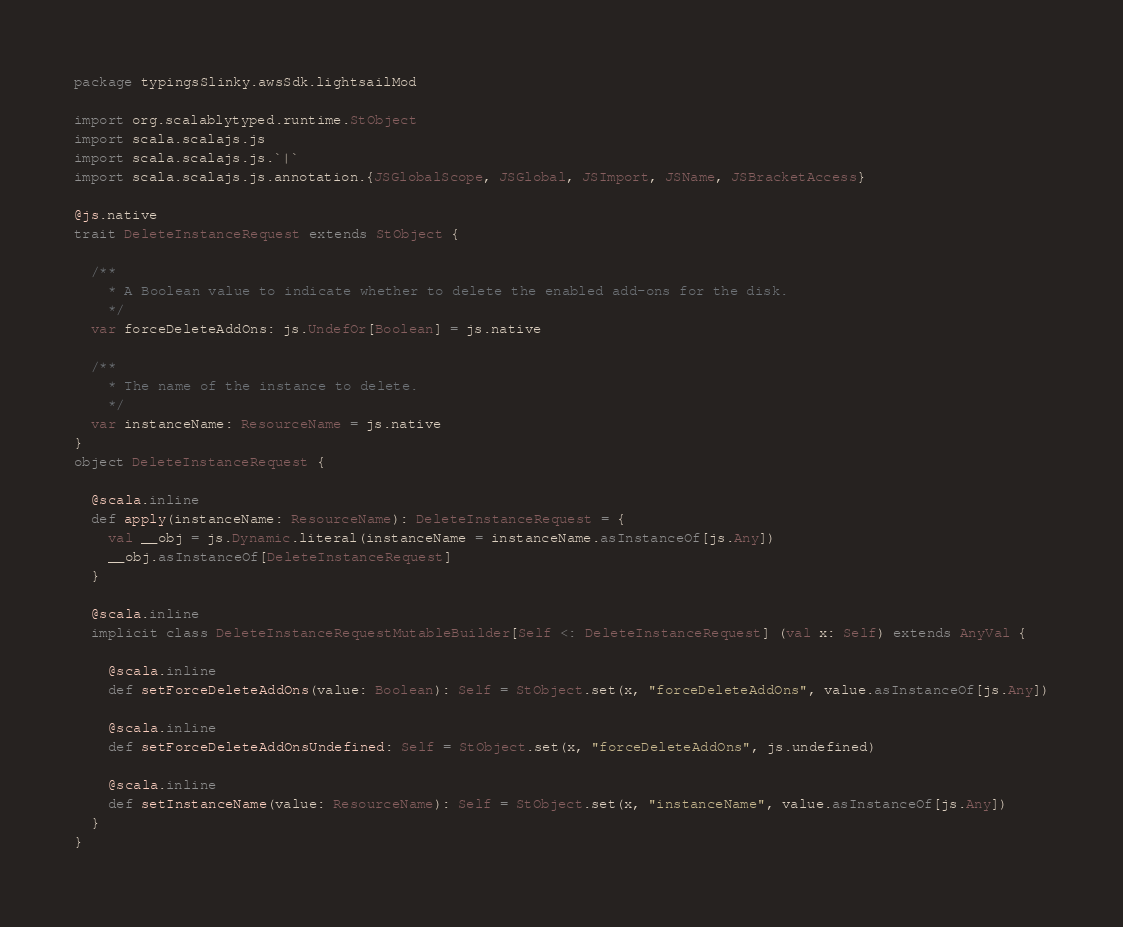<code> <loc_0><loc_0><loc_500><loc_500><_Scala_>package typingsSlinky.awsSdk.lightsailMod

import org.scalablytyped.runtime.StObject
import scala.scalajs.js
import scala.scalajs.js.`|`
import scala.scalajs.js.annotation.{JSGlobalScope, JSGlobal, JSImport, JSName, JSBracketAccess}

@js.native
trait DeleteInstanceRequest extends StObject {
  
  /**
    * A Boolean value to indicate whether to delete the enabled add-ons for the disk.
    */
  var forceDeleteAddOns: js.UndefOr[Boolean] = js.native
  
  /**
    * The name of the instance to delete.
    */
  var instanceName: ResourceName = js.native
}
object DeleteInstanceRequest {
  
  @scala.inline
  def apply(instanceName: ResourceName): DeleteInstanceRequest = {
    val __obj = js.Dynamic.literal(instanceName = instanceName.asInstanceOf[js.Any])
    __obj.asInstanceOf[DeleteInstanceRequest]
  }
  
  @scala.inline
  implicit class DeleteInstanceRequestMutableBuilder[Self <: DeleteInstanceRequest] (val x: Self) extends AnyVal {
    
    @scala.inline
    def setForceDeleteAddOns(value: Boolean): Self = StObject.set(x, "forceDeleteAddOns", value.asInstanceOf[js.Any])
    
    @scala.inline
    def setForceDeleteAddOnsUndefined: Self = StObject.set(x, "forceDeleteAddOns", js.undefined)
    
    @scala.inline
    def setInstanceName(value: ResourceName): Self = StObject.set(x, "instanceName", value.asInstanceOf[js.Any])
  }
}
</code> 